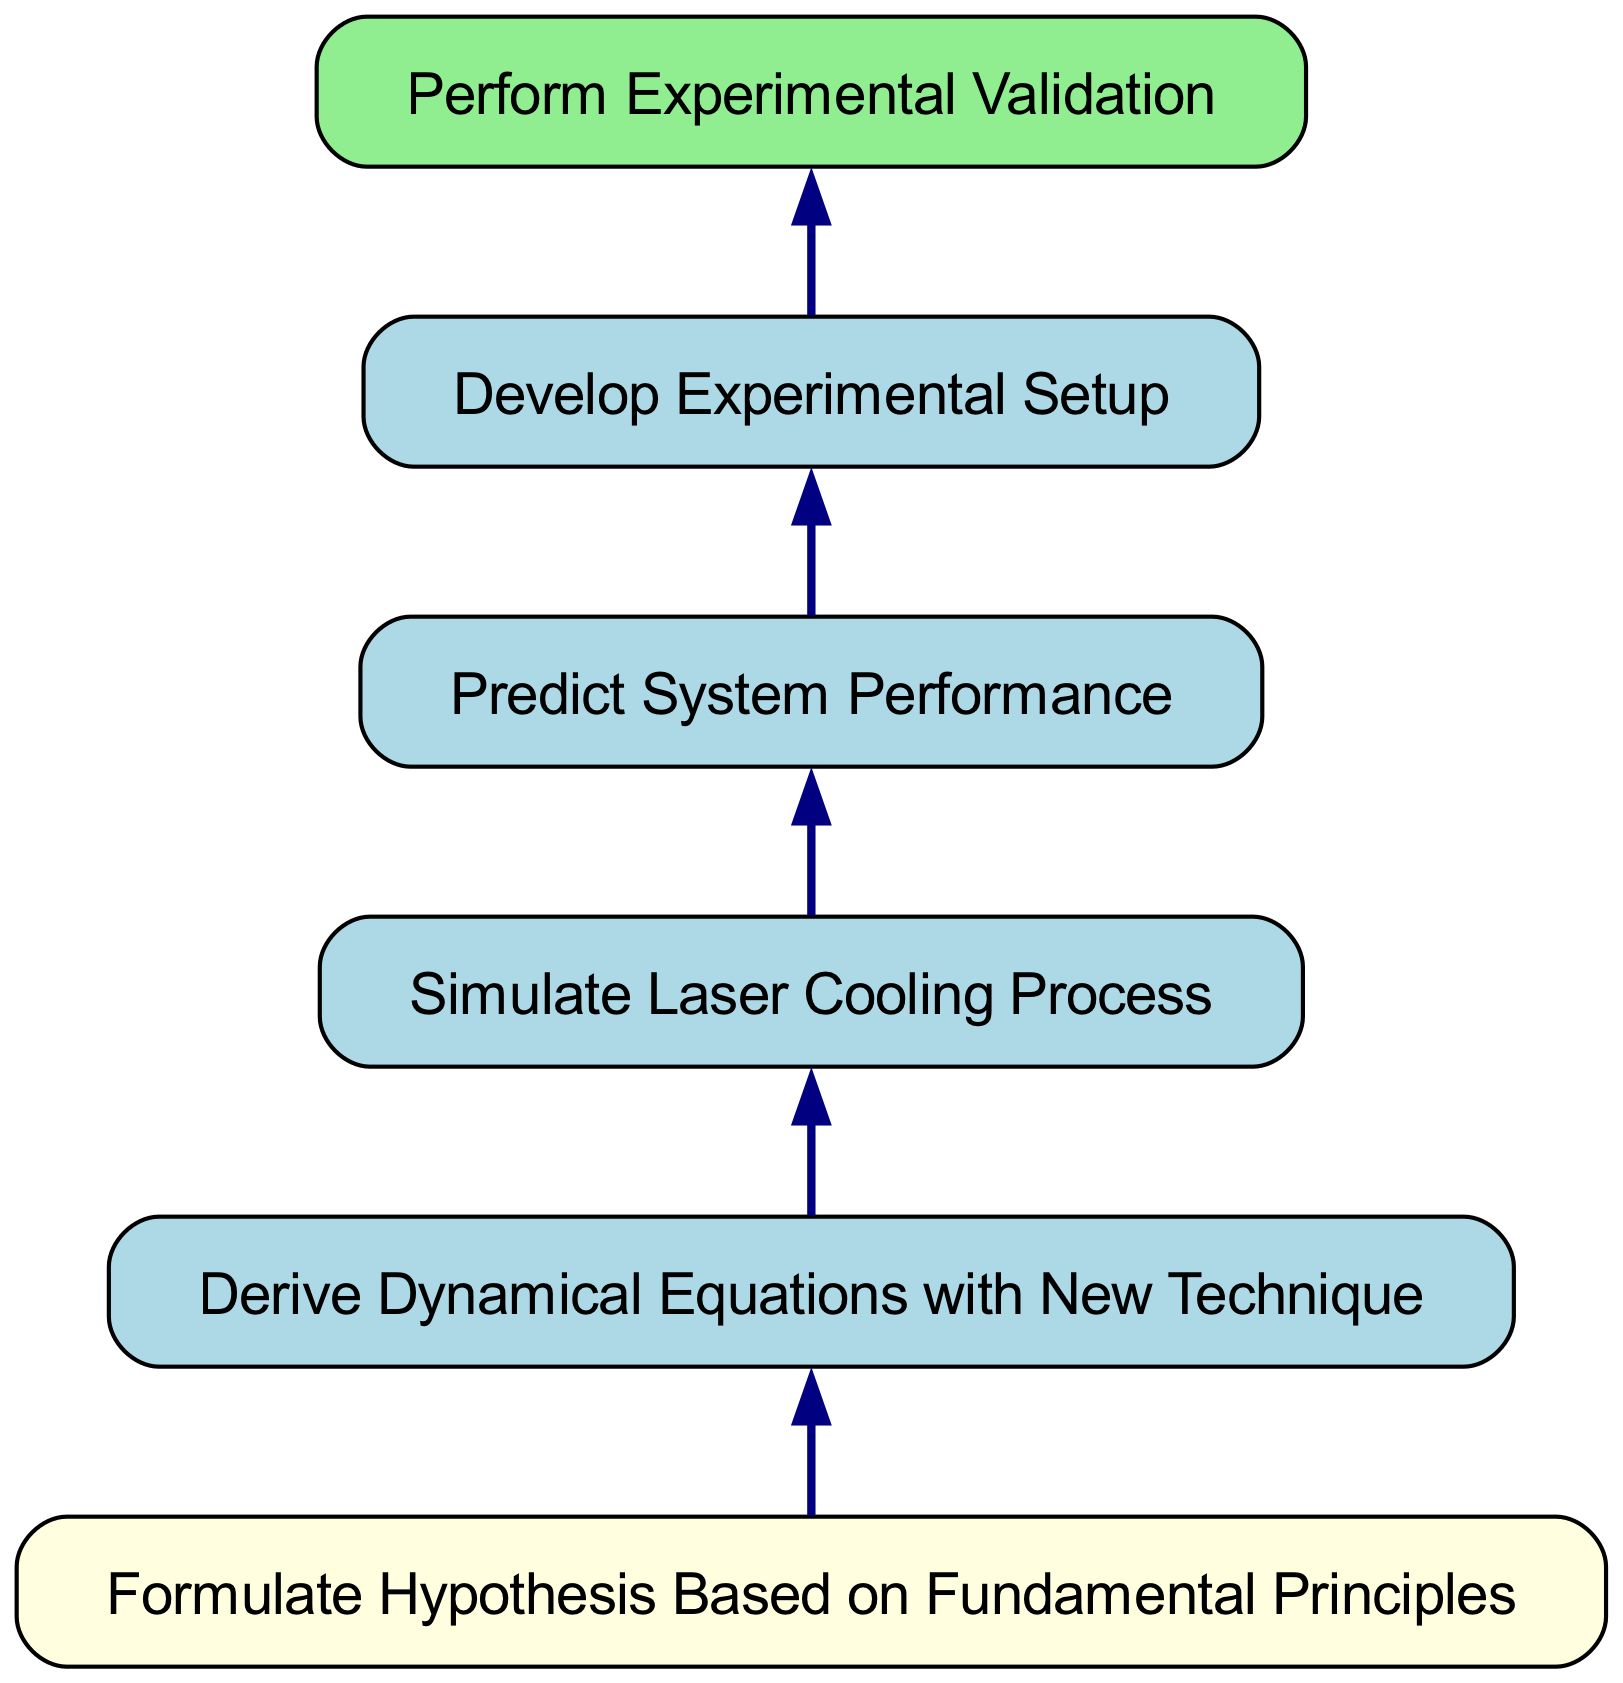What is the topmost node in the diagram? The topmost node in the diagram is "Perform Experimental Validation." This is determined by looking at the hierarchy of the nodes, with "Experimental Validation" being the final step that does not depend on any other nodes.
Answer: Perform Experimental Validation How many nodes are present in the diagram? The diagram contains a total of six nodes, including all steps from hypothesis formulation to experimental validation. Each step represents a part of the process, contributing to the overall development of the new cooling technique.
Answer: Six Which node directly depends on "Formulate Hypothesis Based on Fundamental Principles"? The node that directly depends on "Formulate Hypothesis Based on Fundamental Principles" is "Derive Dynamical Equations with New Technique." This is evidenced by the arrow pointing from the hypothesis node to the dynamical equations node in the flowchart.
Answer: Derive Dynamical Equations with New Technique What is the last step before conducting experimental validation? The last step before conducting experimental validation is "Develop Experimental Setup." This can be seen as the node immediately preceding "Perform Experimental Validation" in the upward flow of the diagram.
Answer: Develop Experimental Setup Which node represents the first step in the process? The first step in the process is represented by the node "Formulate Hypothesis Based on Fundamental Principles." This is the starting point of the development process as indicated at the bottom of the flowchart.
Answer: Formulate Hypothesis Based on Fundamental Principles Describe the relationship between "Simulate Laser Cooling Process" and "Predict System Performance." The relationship is that "Simulate Laser Cooling Process" precedes "Predict System Performance" in this flowchart, meaning that the simulation needs to be conducted before one can make predictions about the system's performance. This is represented by the directed edge from the simulation node to the prediction node.
Answer: Precedes 